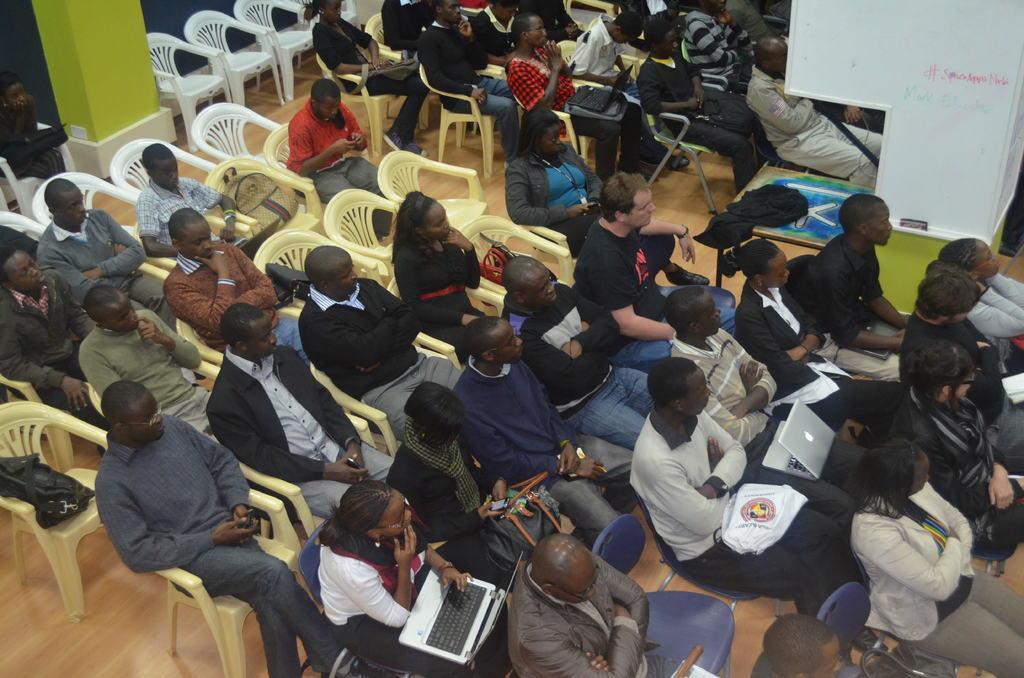Describe this image in one or two sentences. People are sitting on the chair keeping laptop,bag on laps. 